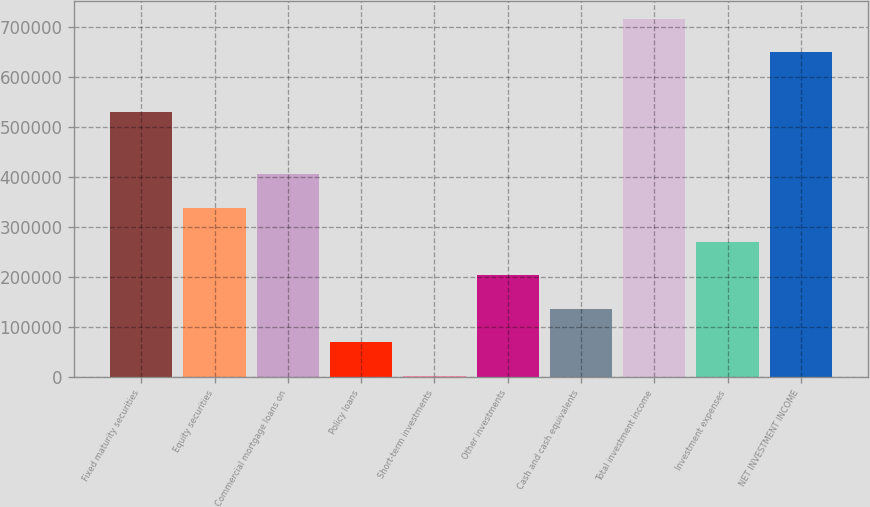Convert chart. <chart><loc_0><loc_0><loc_500><loc_500><bar_chart><fcel>Fixed maturity securities<fcel>Equity securities<fcel>Commercial mortgage loans on<fcel>Policy loans<fcel>Short-term investments<fcel>Other investments<fcel>Cash and cash equivalents<fcel>Total investment income<fcel>Investment expenses<fcel>NET INVESTMENT INCOME<nl><fcel>530144<fcel>338406<fcel>405656<fcel>69406<fcel>2156<fcel>203906<fcel>136656<fcel>717546<fcel>271156<fcel>650296<nl></chart> 